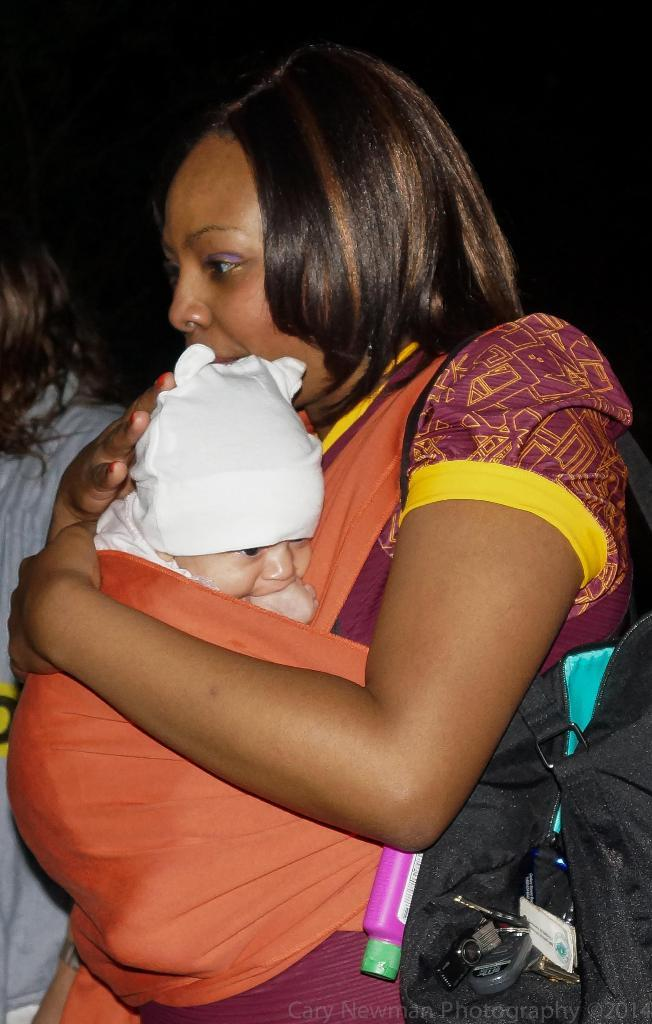Who is the main subject in the foreground of the image? There is a woman in the foreground of the image. What is the woman doing in the image? The woman is holding a baby. What is the woman wearing in the image? The woman is wearing a bag. Can you describe the background of the image? There is a person in the background of the image, and the background appears to be dark. What might be the time of day when the image was taken? The image may have been taken during nighttime, given the dark background. What type of rabbit can be seen wishing the woman a happy birthday in the image? There is no rabbit present in the image, and no birthday wishes are being exchanged. 